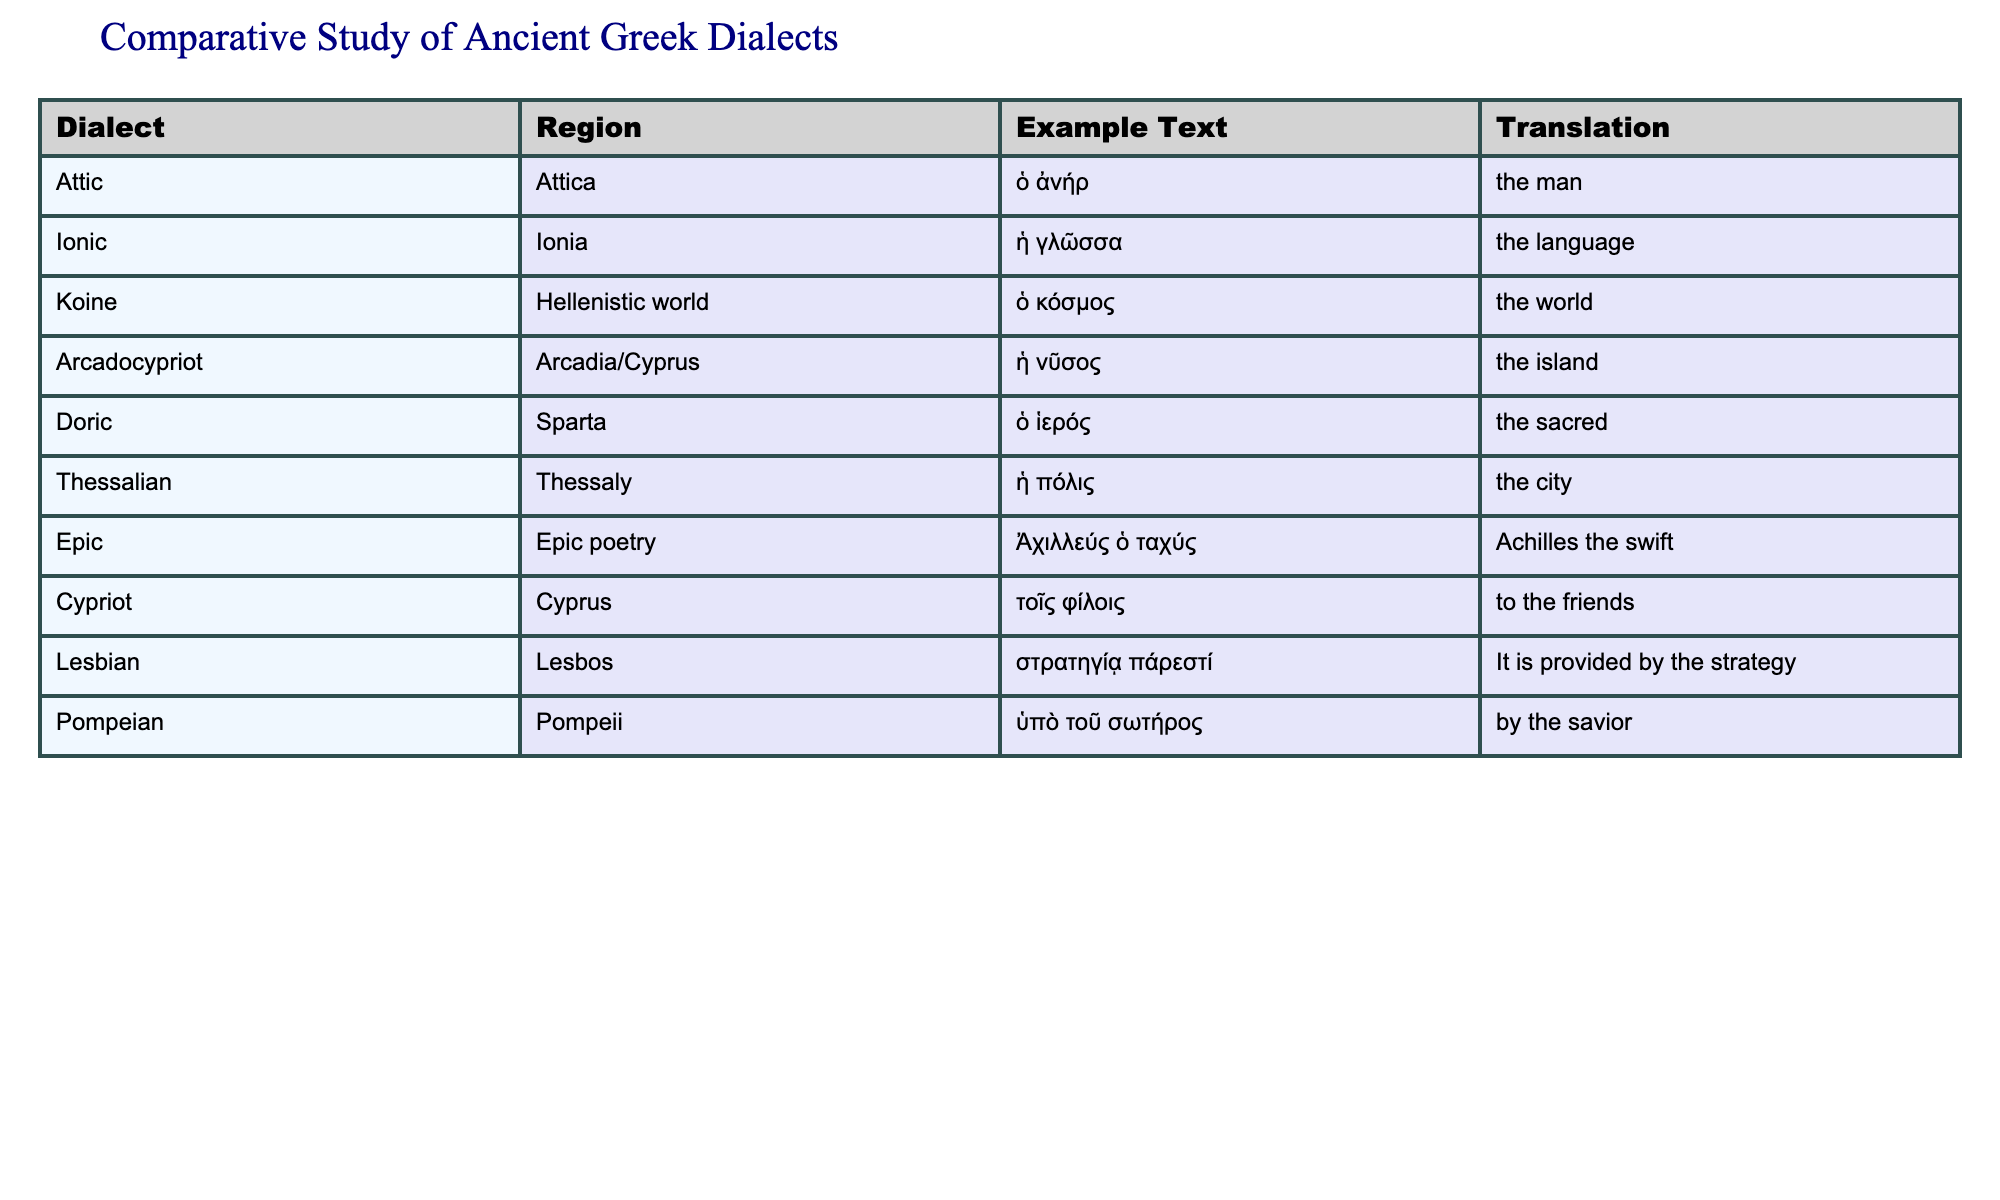What dialect is associated with Arcadia? In the table, "Arcadocypriot" is listed as the dialect that corresponds to the region of Arcadia.
Answer: Arcadocypriot Which example text translates to "the city"? The dialect listed under Thessaly has the example text "ἡ πόλις" which translates to "the city."
Answer: ἡ πόλις Is "Doric" related to the region of Sparta? Yes, the table clearly shows that the dialect of "Doric" is associated with the region of Sparta.
Answer: Yes What is the example text for the Koine dialect? The example text provided for the Koine dialect is "ὁ κόσμος." This can be found directly in the corresponding row under the Example Text column.
Answer: ὁ κόσμος Compare the number of dialects from regions within mainland Greece to those from island regions. In the table, the dialects from mainland Greece include "Attic," "Doric," and "Thessalian," making a total of 3 dialects. The dialects from island regions include "Ionic," "Arcadocypriot," "Cypriot," and "Lesbian," for a total of 4 dialects. Therefore, the comparison shows that there are more dialects from the islands than from mainland Greece.
Answer: Island regions have more dialects What is the translation of "Ἀχιλλεύς ὁ ταχύς"? The translation of the example text "Ἀχιλλεύς ὁ ταχύς" provided under Epic poetry is "Achilles the swift."
Answer: Achilles the swift Are there any dialects listed from the Hellenistic world? Yes, the Koine dialect is listed with its region as the Hellenistic world in the table.
Answer: Yes Which dialect has the longest example text? The dialect with the longest example text is "Lesbian," which has "στρατηγίᾳ πάρεστί" consisting of five words compared to the other examples.
Answer: Lesbian 